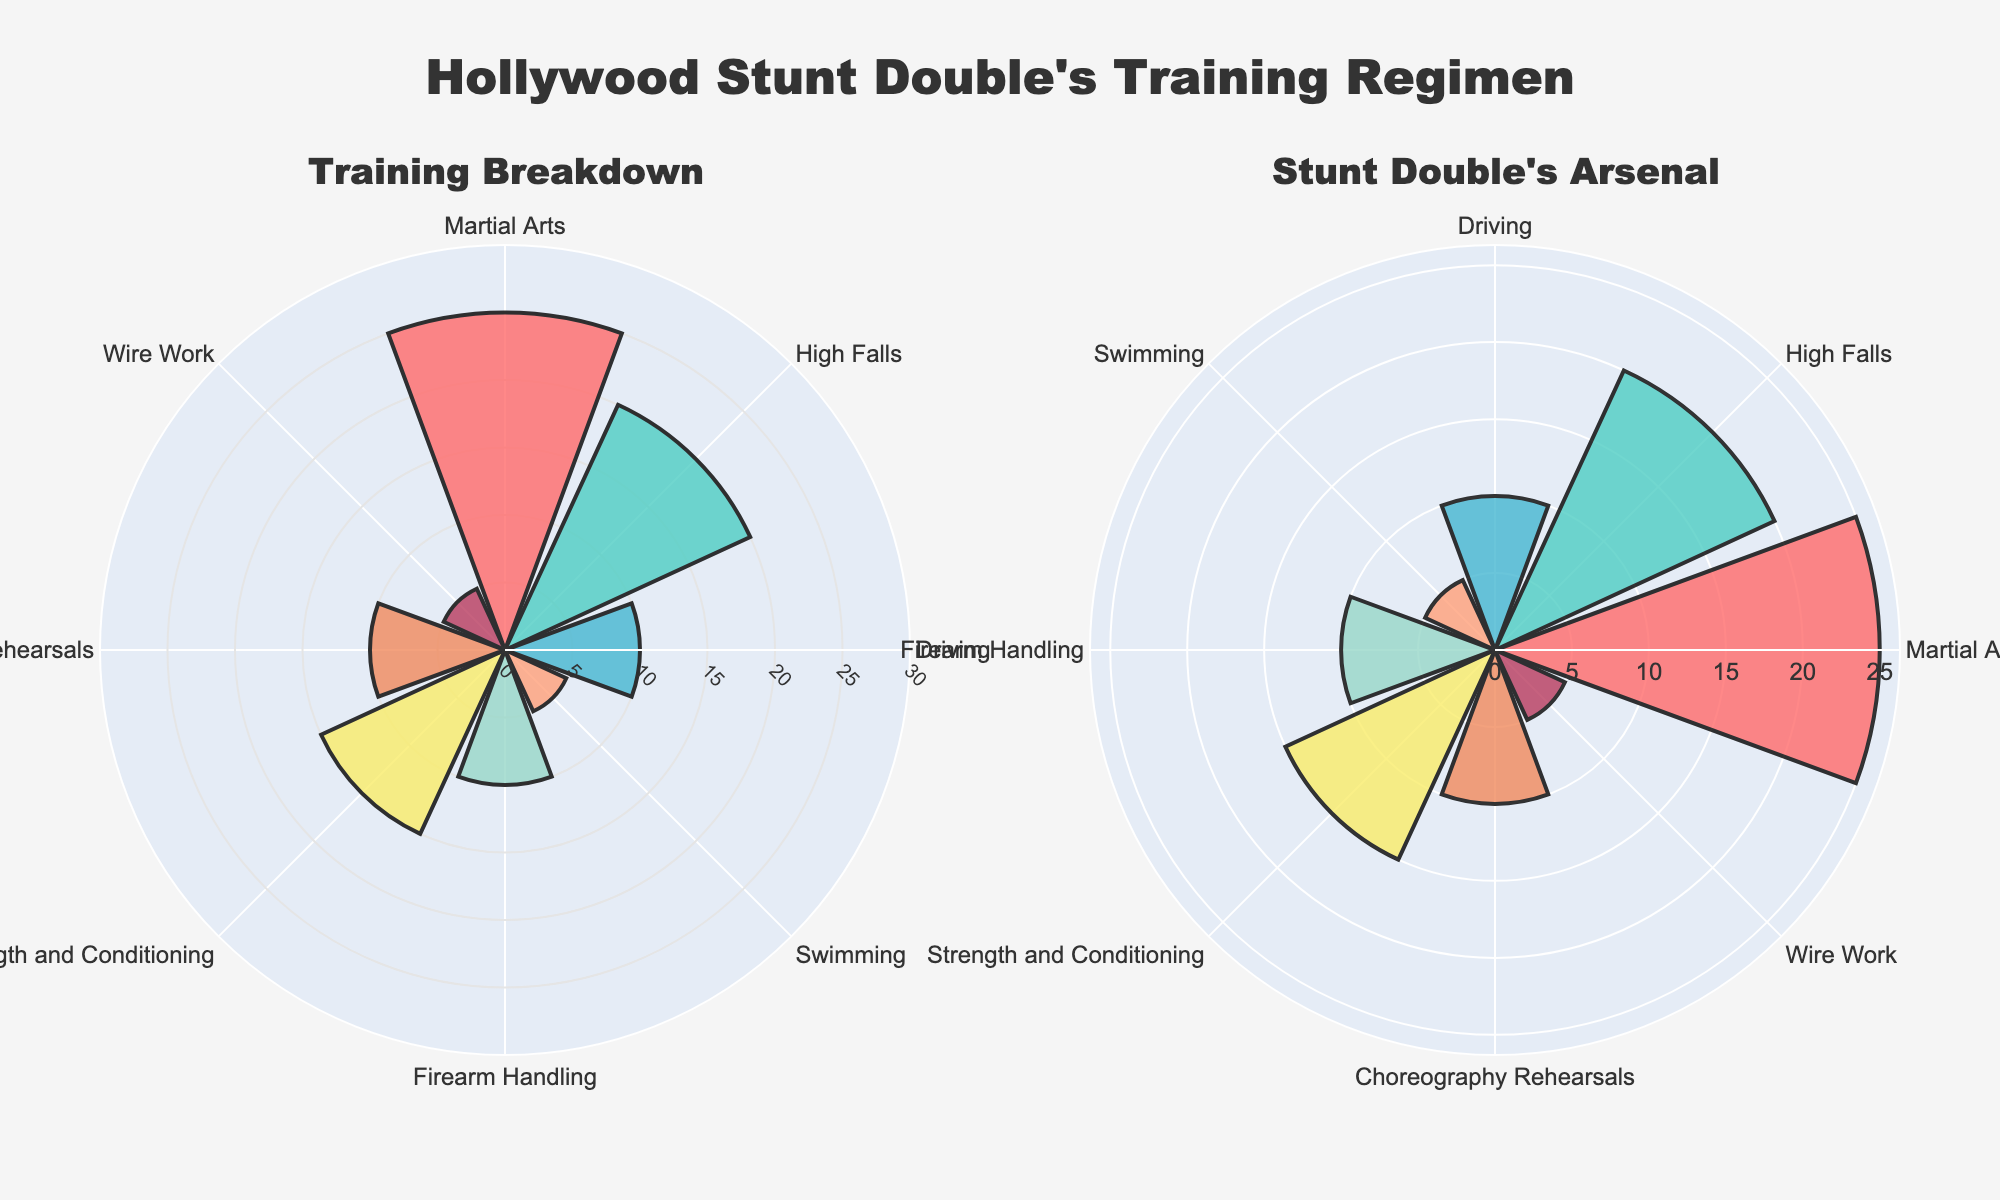what is the title of the figure? The title is displayed prominently at the top of the figure. It reads "Hollywood Stunt Double's Training Regimen", which gives an overall idea about the data represented in the plots.
Answer: Hollywood Stunt Double's Training Regimen how many training types are illustrated in the plots? By counting the segments or labels displayed around the rose charts, we can see that there are 8 different types of training represented.
Answer: 8 Which training type has the highest proportion? By examining the lengths or sizes of the segments, it is clear that 'Martial Arts' has the largest segment, indicating the highest proportion.
Answer: Martial Arts what is the proportion of time spent on driving compared to swimming? From the values given in the plot, 'Driving' has a proportion of 10 and 'Swimming' has a proportion of 5. Comparing these, 'Driving' has a higher proportion than 'Swimming'.
Answer: Driving what are the combined proportions for Martial Arts and Strength and Conditioning? The proportion for 'Martial Arts' is 25 and for 'Strength and Conditioning' is 15. By adding these two proportions, we get 25 + 15 = 40.
Answer: 40 which training type has the smallest proportion? By looking at the lengths of the segments, 'Swimming' and 'Wire Work' both appear to have the smallest segment, indicating they have the smallest proportions.
Answer: Swimming and Wire Work what is the total proportion of time spent on High Falls, Choreography Rehearsals, and Firearm Handling? The proportion for 'High Falls' is 20, 'Choreography Rehearsals' is 10, and 'Firearm Handling' is 10. Adding these, we get 20 + 10 + 10 = 40.
Answer: 40 What training type has a proportion equal to that of Driving? According to the figure, 'Driving' has a proportion of 10. 'Firearm Handling' also has a proportion of 10, indicating they are equal.
Answer: Firearm Handling How does the time spent on Strength and Conditioning compare to Choreography Rehearsals? The proportion for 'Strength and Conditioning' is 15 while 'Choreography Rehearsals' has a proportion of 10. Hence, more time is spent on 'Strength and Conditioning'.
Answer: Strength and Conditioning 